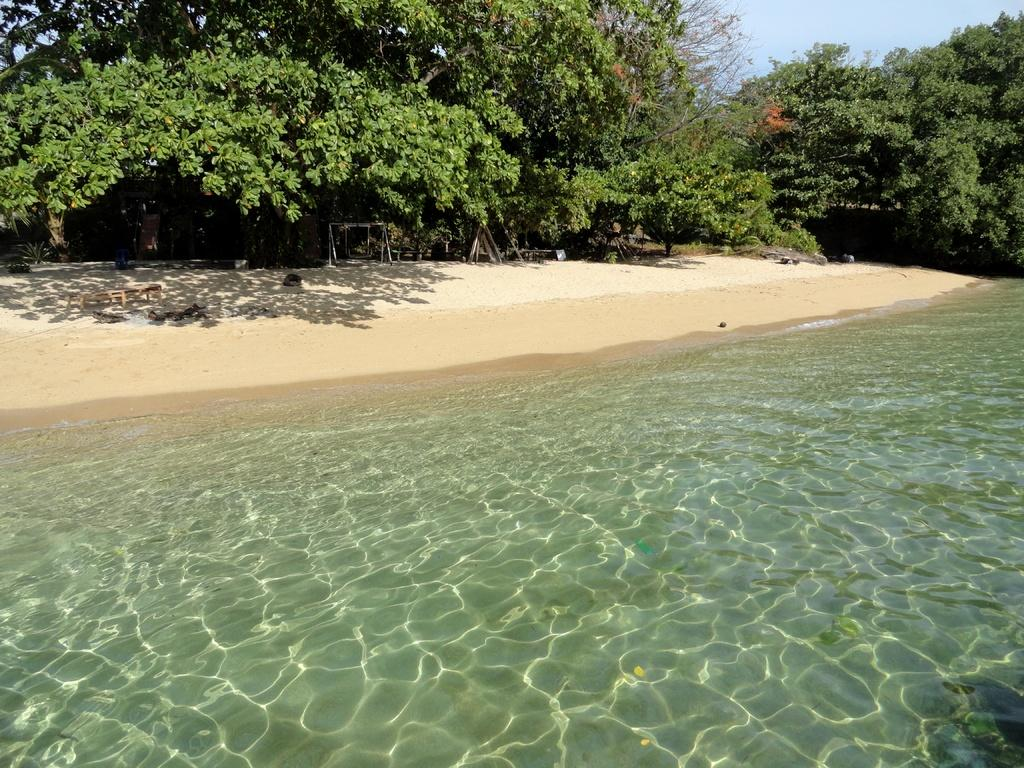What type of location is shown in the image? The image depicts a beach view. What can be seen in the front of the image? There is water visible in the front of the image. What is located behind the water? There is sand behind the water. What can be seen in the distance in the image? There are trees visible in the background. How much money is in the bag on the beach in the image? There is no bag or mention of money in the image; it only shows a beach view with water, sand, and trees. 